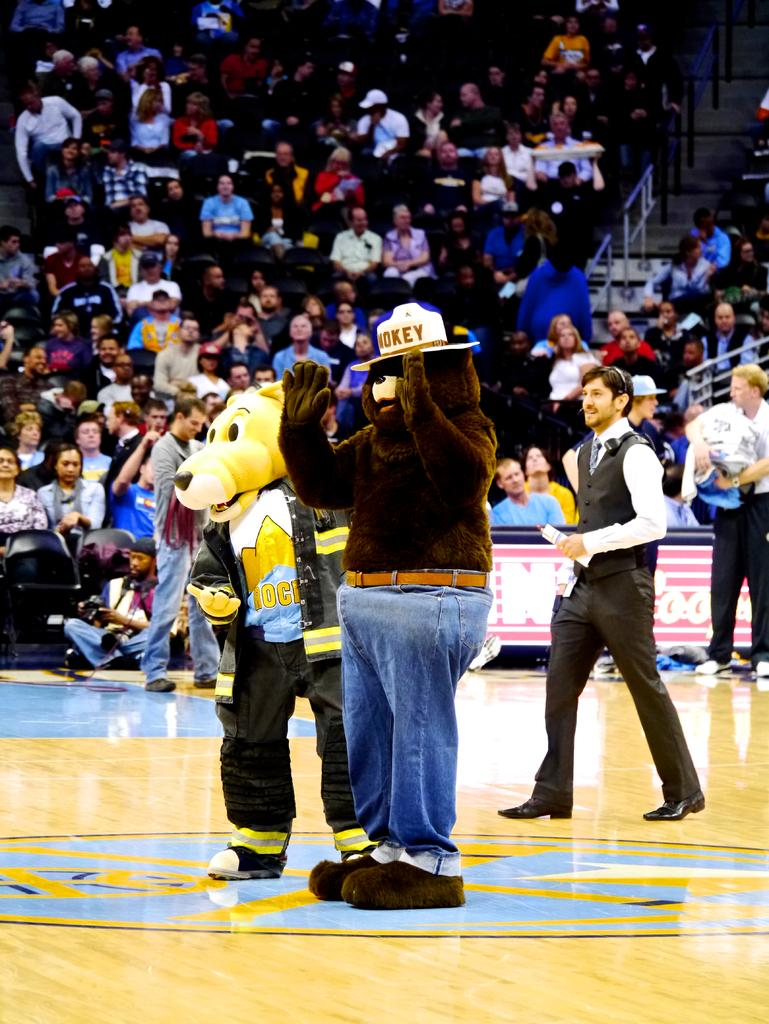What can be seen in the image? There are two mascots in the image. Where are the mascots located? The mascots are on a ground. Are there any people near the mascots? Yes, there are people standing around the mascots. What is happening in the background of the image? In the background of the image, people are sitting on chairs. Can you tell me how many times the mascots have used the oven in the image? There is no oven present in the image, so it is not possible to determine how many times the mascots have used it. 